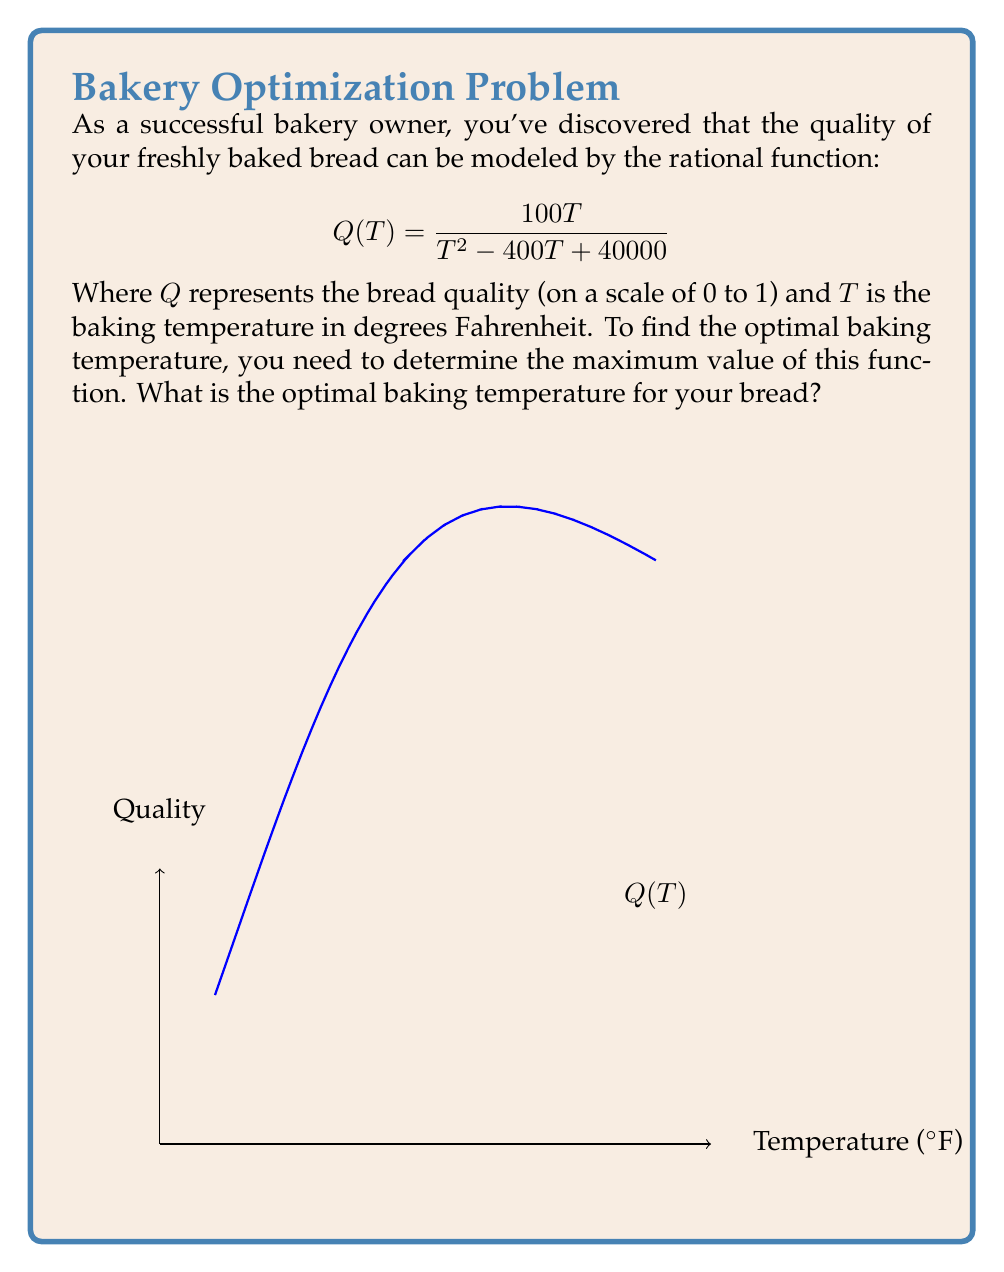Can you solve this math problem? To find the optimal baking temperature, we need to find the maximum value of the rational function $Q(T)$. Here's how we can do this:

1) First, let's find the derivative of $Q(T)$ using the quotient rule:

   $$Q'(T) = \frac{(T^2 - 400T + 40000)(100) - 100T(2T - 400)}{(T^2 - 400T + 40000)^2}$$

2) Simplify the numerator:

   $$Q'(T) = \frac{100T^2 - 40000T + 4000000 - 200T^2 + 40000T}{(T^2 - 400T + 40000)^2}$$
   
   $$Q'(T) = \frac{-100T^2 + 4000000}{(T^2 - 400T + 40000)^2}$$

3) To find the maximum, set $Q'(T) = 0$ and solve for $T$:

   $$-100T^2 + 4000000 = 0$$
   $$T^2 = 40000$$
   $$T = \pm 200$$

4) Since temperature can't be negative, we take the positive root: $T = 200$.

5) To confirm this is a maximum (not a minimum), we can check the second derivative or observe the behavior of the function around this point.

Therefore, the optimal baking temperature is 200°F.
Answer: 200°F 